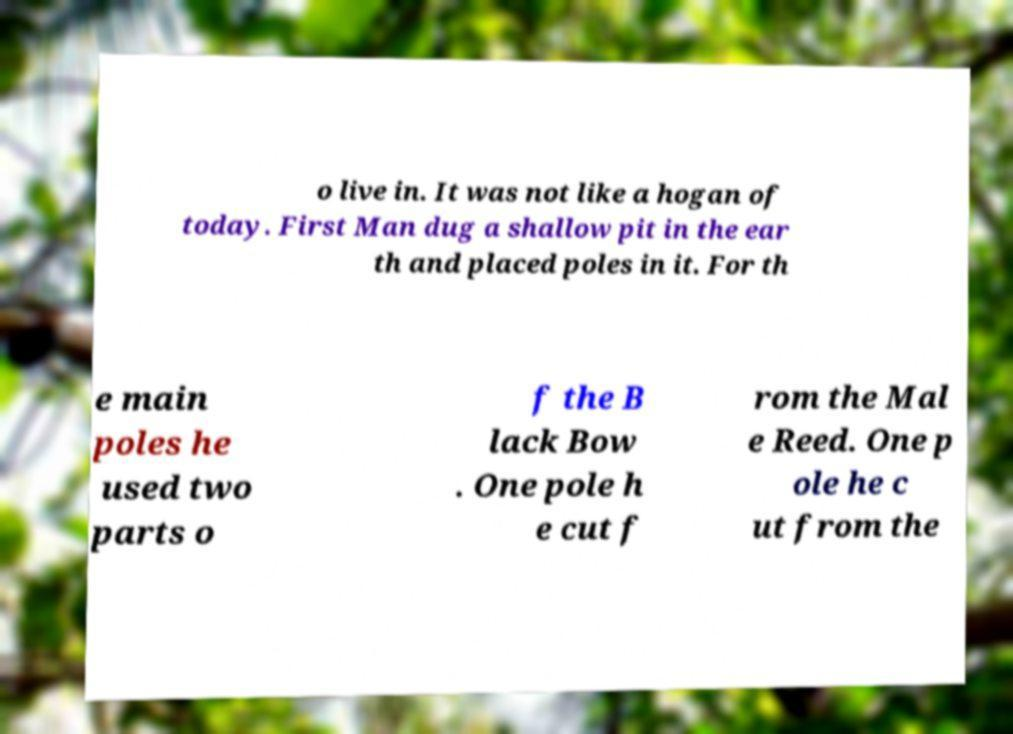For documentation purposes, I need the text within this image transcribed. Could you provide that? o live in. It was not like a hogan of today. First Man dug a shallow pit in the ear th and placed poles in it. For th e main poles he used two parts o f the B lack Bow . One pole h e cut f rom the Mal e Reed. One p ole he c ut from the 